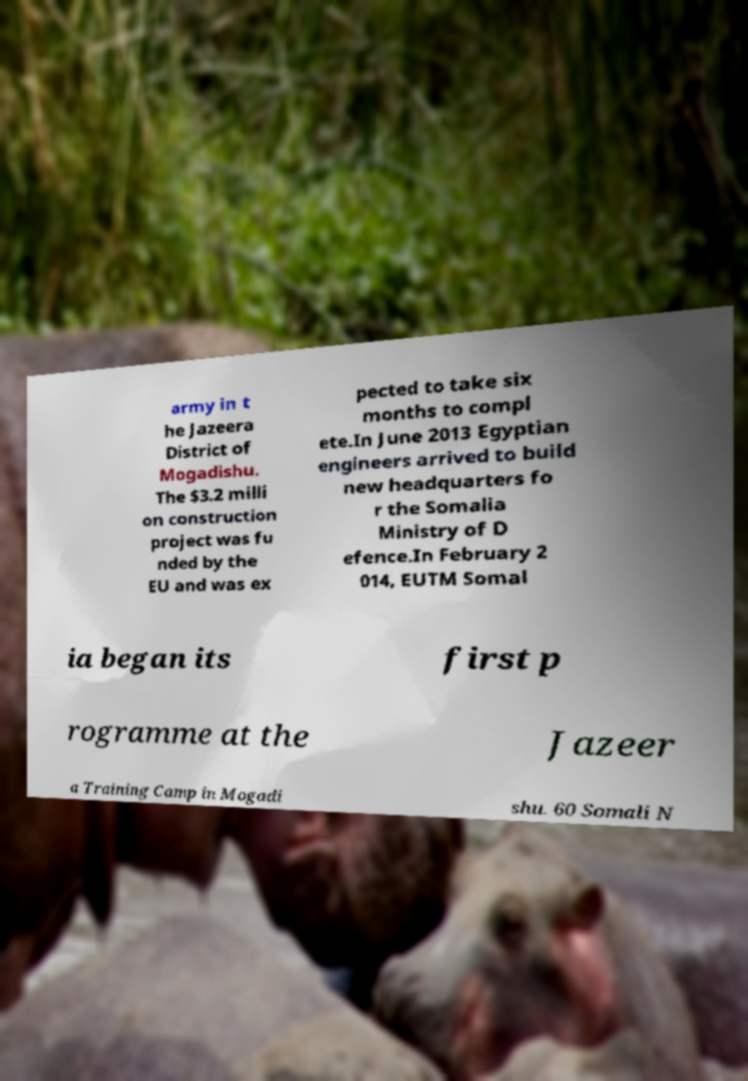Can you accurately transcribe the text from the provided image for me? army in t he Jazeera District of Mogadishu. The $3.2 milli on construction project was fu nded by the EU and was ex pected to take six months to compl ete.In June 2013 Egyptian engineers arrived to build new headquarters fo r the Somalia Ministry of D efence.In February 2 014, EUTM Somal ia began its first p rogramme at the Jazeer a Training Camp in Mogadi shu. 60 Somali N 